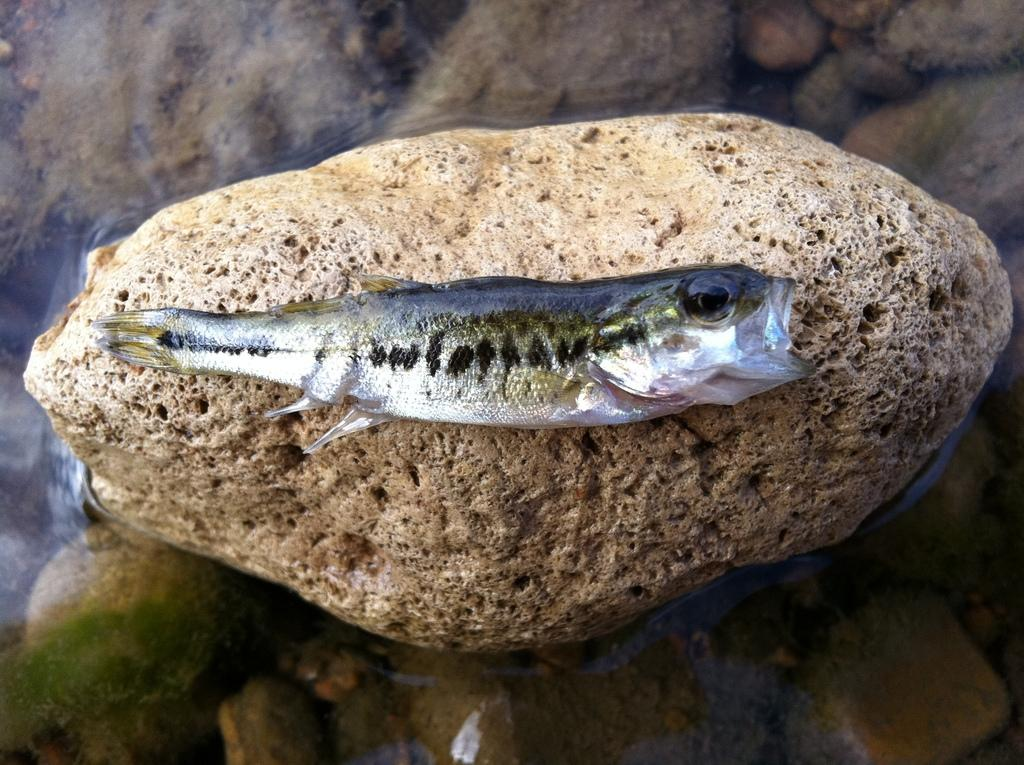What type of animal is in the image? There is a fish in the image. Where is the fish located? The fish is on a rock. What is the rock resting on? The rock is on the surface of the water. How does the goose interact with the fish in the image? There is no goose present in the image, so it cannot interact with the fish. 